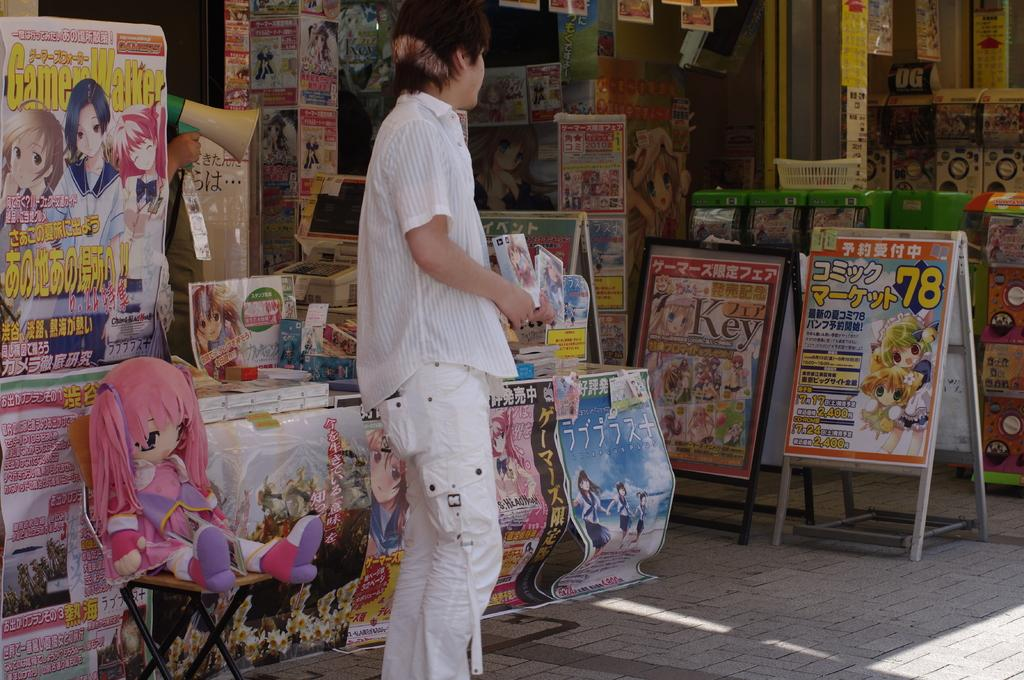<image>
Offer a succinct explanation of the picture presented. A person stands in front of a store that is selling anime merchandise, including a Game Walker. 